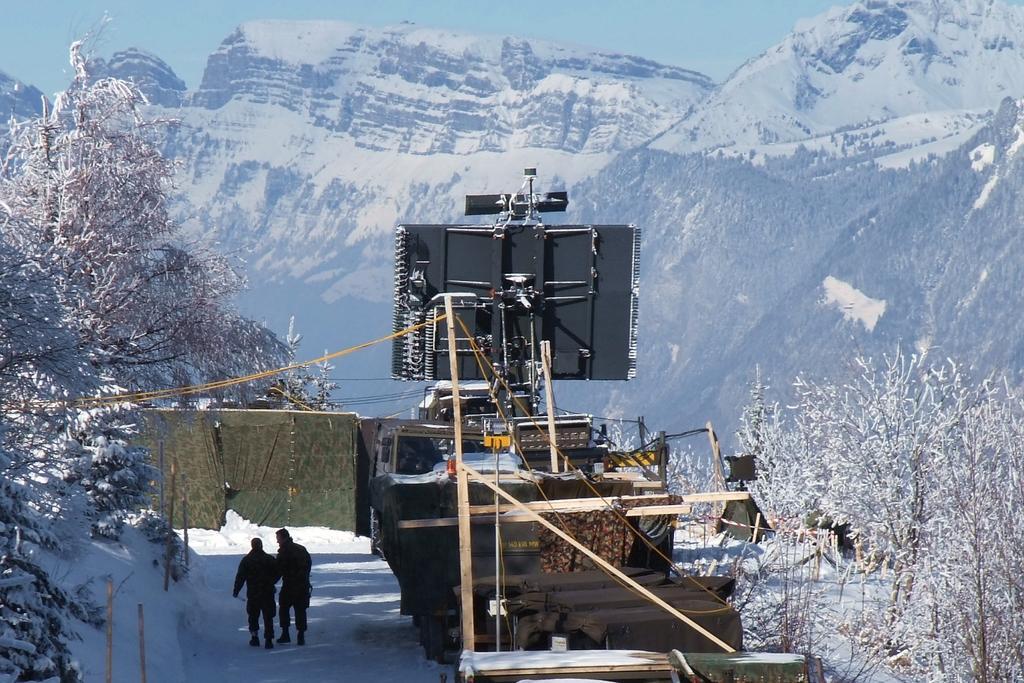How would you summarize this image in a sentence or two? In this image we can see two persons on the snow, there are few trees with snow, there are sticks, an object looks like a vehicle, an electronic device, mountains and the sky in the background. 